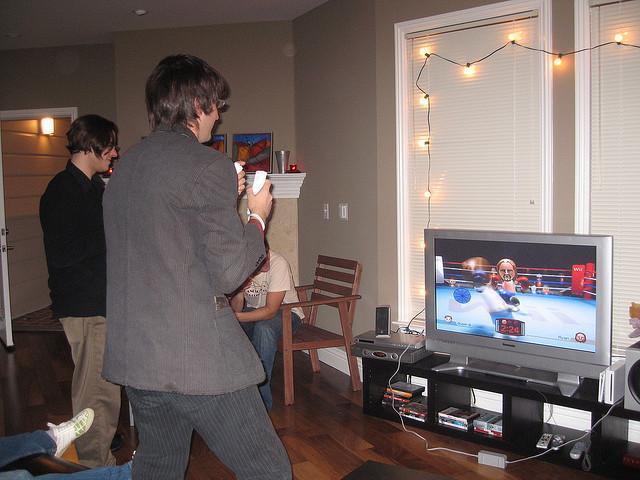How many people are playing video games?
Give a very brief answer. 2. How many windows are there?
Give a very brief answer. 2. How many people are there?
Give a very brief answer. 4. How many cars are heading toward the train?
Give a very brief answer. 0. 